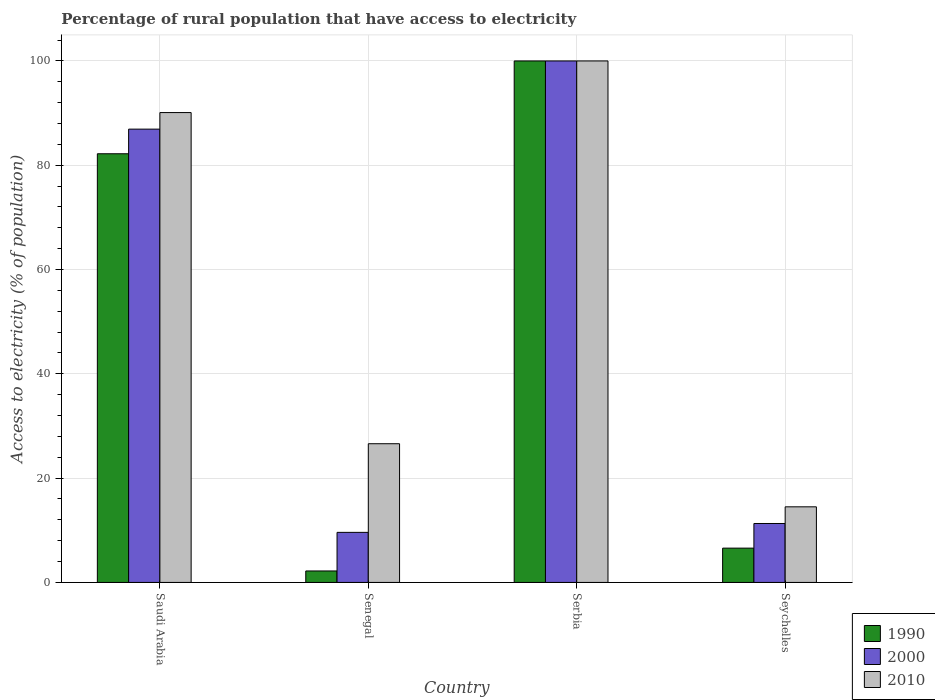How many different coloured bars are there?
Make the answer very short. 3. How many groups of bars are there?
Keep it short and to the point. 4. Are the number of bars per tick equal to the number of legend labels?
Keep it short and to the point. Yes. Are the number of bars on each tick of the X-axis equal?
Offer a terse response. Yes. How many bars are there on the 1st tick from the left?
Make the answer very short. 3. How many bars are there on the 2nd tick from the right?
Your response must be concise. 3. What is the label of the 2nd group of bars from the left?
Your response must be concise. Senegal. In how many cases, is the number of bars for a given country not equal to the number of legend labels?
Offer a very short reply. 0. What is the percentage of rural population that have access to electricity in 1990 in Seychelles?
Give a very brief answer. 6.58. Across all countries, what is the minimum percentage of rural population that have access to electricity in 2010?
Your answer should be compact. 14.5. In which country was the percentage of rural population that have access to electricity in 2000 maximum?
Your response must be concise. Serbia. In which country was the percentage of rural population that have access to electricity in 2000 minimum?
Make the answer very short. Senegal. What is the total percentage of rural population that have access to electricity in 2010 in the graph?
Give a very brief answer. 231.2. What is the difference between the percentage of rural population that have access to electricity in 2000 in Senegal and that in Seychelles?
Provide a short and direct response. -1.7. What is the difference between the percentage of rural population that have access to electricity in 2010 in Senegal and the percentage of rural population that have access to electricity in 1990 in Saudi Arabia?
Keep it short and to the point. -55.6. What is the average percentage of rural population that have access to electricity in 1990 per country?
Your answer should be compact. 47.75. What is the difference between the percentage of rural population that have access to electricity of/in 2010 and percentage of rural population that have access to electricity of/in 2000 in Senegal?
Keep it short and to the point. 17. In how many countries, is the percentage of rural population that have access to electricity in 2010 greater than 4 %?
Offer a terse response. 4. What is the ratio of the percentage of rural population that have access to electricity in 1990 in Saudi Arabia to that in Senegal?
Make the answer very short. 37.37. What is the difference between the highest and the second highest percentage of rural population that have access to electricity in 2000?
Your answer should be compact. -88.7. What is the difference between the highest and the lowest percentage of rural population that have access to electricity in 1990?
Offer a terse response. 97.8. In how many countries, is the percentage of rural population that have access to electricity in 1990 greater than the average percentage of rural population that have access to electricity in 1990 taken over all countries?
Ensure brevity in your answer.  2. Is it the case that in every country, the sum of the percentage of rural population that have access to electricity in 1990 and percentage of rural population that have access to electricity in 2010 is greater than the percentage of rural population that have access to electricity in 2000?
Give a very brief answer. Yes. How many countries are there in the graph?
Your answer should be very brief. 4. Are the values on the major ticks of Y-axis written in scientific E-notation?
Your answer should be very brief. No. Does the graph contain any zero values?
Your answer should be very brief. No. Where does the legend appear in the graph?
Your answer should be very brief. Bottom right. How are the legend labels stacked?
Offer a very short reply. Vertical. What is the title of the graph?
Provide a short and direct response. Percentage of rural population that have access to electricity. Does "1972" appear as one of the legend labels in the graph?
Provide a short and direct response. No. What is the label or title of the Y-axis?
Offer a terse response. Access to electricity (% of population). What is the Access to electricity (% of population) of 1990 in Saudi Arabia?
Give a very brief answer. 82.2. What is the Access to electricity (% of population) in 2000 in Saudi Arabia?
Your answer should be very brief. 86.93. What is the Access to electricity (% of population) of 2010 in Saudi Arabia?
Provide a succinct answer. 90.1. What is the Access to electricity (% of population) of 1990 in Senegal?
Make the answer very short. 2.2. What is the Access to electricity (% of population) in 2000 in Senegal?
Your response must be concise. 9.6. What is the Access to electricity (% of population) in 2010 in Senegal?
Provide a succinct answer. 26.6. What is the Access to electricity (% of population) of 1990 in Seychelles?
Offer a very short reply. 6.58. What is the Access to electricity (% of population) of 2000 in Seychelles?
Your answer should be very brief. 11.3. Across all countries, what is the maximum Access to electricity (% of population) in 1990?
Provide a short and direct response. 100. Across all countries, what is the minimum Access to electricity (% of population) of 1990?
Provide a short and direct response. 2.2. Across all countries, what is the minimum Access to electricity (% of population) of 2000?
Your response must be concise. 9.6. What is the total Access to electricity (% of population) of 1990 in the graph?
Provide a short and direct response. 190.98. What is the total Access to electricity (% of population) in 2000 in the graph?
Your answer should be compact. 207.83. What is the total Access to electricity (% of population) in 2010 in the graph?
Make the answer very short. 231.2. What is the difference between the Access to electricity (% of population) in 1990 in Saudi Arabia and that in Senegal?
Give a very brief answer. 80. What is the difference between the Access to electricity (% of population) in 2000 in Saudi Arabia and that in Senegal?
Your answer should be very brief. 77.33. What is the difference between the Access to electricity (% of population) in 2010 in Saudi Arabia and that in Senegal?
Offer a terse response. 63.5. What is the difference between the Access to electricity (% of population) of 1990 in Saudi Arabia and that in Serbia?
Offer a terse response. -17.8. What is the difference between the Access to electricity (% of population) in 2000 in Saudi Arabia and that in Serbia?
Provide a short and direct response. -13.07. What is the difference between the Access to electricity (% of population) in 1990 in Saudi Arabia and that in Seychelles?
Provide a short and direct response. 75.62. What is the difference between the Access to electricity (% of population) of 2000 in Saudi Arabia and that in Seychelles?
Your answer should be very brief. 75.62. What is the difference between the Access to electricity (% of population) in 2010 in Saudi Arabia and that in Seychelles?
Give a very brief answer. 75.6. What is the difference between the Access to electricity (% of population) in 1990 in Senegal and that in Serbia?
Provide a succinct answer. -97.8. What is the difference between the Access to electricity (% of population) in 2000 in Senegal and that in Serbia?
Ensure brevity in your answer.  -90.4. What is the difference between the Access to electricity (% of population) of 2010 in Senegal and that in Serbia?
Ensure brevity in your answer.  -73.4. What is the difference between the Access to electricity (% of population) of 1990 in Senegal and that in Seychelles?
Your response must be concise. -4.38. What is the difference between the Access to electricity (% of population) in 2000 in Senegal and that in Seychelles?
Keep it short and to the point. -1.7. What is the difference between the Access to electricity (% of population) in 2010 in Senegal and that in Seychelles?
Provide a short and direct response. 12.1. What is the difference between the Access to electricity (% of population) of 1990 in Serbia and that in Seychelles?
Offer a terse response. 93.42. What is the difference between the Access to electricity (% of population) of 2000 in Serbia and that in Seychelles?
Provide a short and direct response. 88.7. What is the difference between the Access to electricity (% of population) of 2010 in Serbia and that in Seychelles?
Keep it short and to the point. 85.5. What is the difference between the Access to electricity (% of population) in 1990 in Saudi Arabia and the Access to electricity (% of population) in 2000 in Senegal?
Offer a terse response. 72.6. What is the difference between the Access to electricity (% of population) in 1990 in Saudi Arabia and the Access to electricity (% of population) in 2010 in Senegal?
Provide a succinct answer. 55.6. What is the difference between the Access to electricity (% of population) of 2000 in Saudi Arabia and the Access to electricity (% of population) of 2010 in Senegal?
Give a very brief answer. 60.33. What is the difference between the Access to electricity (% of population) in 1990 in Saudi Arabia and the Access to electricity (% of population) in 2000 in Serbia?
Give a very brief answer. -17.8. What is the difference between the Access to electricity (% of population) in 1990 in Saudi Arabia and the Access to electricity (% of population) in 2010 in Serbia?
Keep it short and to the point. -17.8. What is the difference between the Access to electricity (% of population) in 2000 in Saudi Arabia and the Access to electricity (% of population) in 2010 in Serbia?
Provide a short and direct response. -13.07. What is the difference between the Access to electricity (% of population) of 1990 in Saudi Arabia and the Access to electricity (% of population) of 2000 in Seychelles?
Provide a succinct answer. 70.9. What is the difference between the Access to electricity (% of population) in 1990 in Saudi Arabia and the Access to electricity (% of population) in 2010 in Seychelles?
Give a very brief answer. 67.7. What is the difference between the Access to electricity (% of population) of 2000 in Saudi Arabia and the Access to electricity (% of population) of 2010 in Seychelles?
Provide a succinct answer. 72.43. What is the difference between the Access to electricity (% of population) of 1990 in Senegal and the Access to electricity (% of population) of 2000 in Serbia?
Your answer should be compact. -97.8. What is the difference between the Access to electricity (% of population) of 1990 in Senegal and the Access to electricity (% of population) of 2010 in Serbia?
Provide a succinct answer. -97.8. What is the difference between the Access to electricity (% of population) in 2000 in Senegal and the Access to electricity (% of population) in 2010 in Serbia?
Provide a short and direct response. -90.4. What is the difference between the Access to electricity (% of population) in 1990 in Senegal and the Access to electricity (% of population) in 2000 in Seychelles?
Your answer should be very brief. -9.1. What is the difference between the Access to electricity (% of population) of 1990 in Senegal and the Access to electricity (% of population) of 2010 in Seychelles?
Ensure brevity in your answer.  -12.3. What is the difference between the Access to electricity (% of population) in 2000 in Senegal and the Access to electricity (% of population) in 2010 in Seychelles?
Your answer should be compact. -4.9. What is the difference between the Access to electricity (% of population) in 1990 in Serbia and the Access to electricity (% of population) in 2000 in Seychelles?
Offer a terse response. 88.7. What is the difference between the Access to electricity (% of population) of 1990 in Serbia and the Access to electricity (% of population) of 2010 in Seychelles?
Offer a terse response. 85.5. What is the difference between the Access to electricity (% of population) of 2000 in Serbia and the Access to electricity (% of population) of 2010 in Seychelles?
Keep it short and to the point. 85.5. What is the average Access to electricity (% of population) in 1990 per country?
Make the answer very short. 47.75. What is the average Access to electricity (% of population) of 2000 per country?
Provide a succinct answer. 51.96. What is the average Access to electricity (% of population) in 2010 per country?
Your response must be concise. 57.8. What is the difference between the Access to electricity (% of population) of 1990 and Access to electricity (% of population) of 2000 in Saudi Arabia?
Make the answer very short. -4.72. What is the difference between the Access to electricity (% of population) of 1990 and Access to electricity (% of population) of 2010 in Saudi Arabia?
Offer a terse response. -7.9. What is the difference between the Access to electricity (% of population) of 2000 and Access to electricity (% of population) of 2010 in Saudi Arabia?
Make the answer very short. -3.17. What is the difference between the Access to electricity (% of population) in 1990 and Access to electricity (% of population) in 2000 in Senegal?
Keep it short and to the point. -7.4. What is the difference between the Access to electricity (% of population) of 1990 and Access to electricity (% of population) of 2010 in Senegal?
Give a very brief answer. -24.4. What is the difference between the Access to electricity (% of population) of 2000 and Access to electricity (% of population) of 2010 in Senegal?
Offer a terse response. -17. What is the difference between the Access to electricity (% of population) of 1990 and Access to electricity (% of population) of 2000 in Serbia?
Provide a succinct answer. 0. What is the difference between the Access to electricity (% of population) in 2000 and Access to electricity (% of population) in 2010 in Serbia?
Provide a short and direct response. 0. What is the difference between the Access to electricity (% of population) in 1990 and Access to electricity (% of population) in 2000 in Seychelles?
Your answer should be compact. -4.72. What is the difference between the Access to electricity (% of population) of 1990 and Access to electricity (% of population) of 2010 in Seychelles?
Provide a short and direct response. -7.92. What is the difference between the Access to electricity (% of population) of 2000 and Access to electricity (% of population) of 2010 in Seychelles?
Give a very brief answer. -3.2. What is the ratio of the Access to electricity (% of population) of 1990 in Saudi Arabia to that in Senegal?
Your response must be concise. 37.37. What is the ratio of the Access to electricity (% of population) of 2000 in Saudi Arabia to that in Senegal?
Keep it short and to the point. 9.05. What is the ratio of the Access to electricity (% of population) of 2010 in Saudi Arabia to that in Senegal?
Provide a short and direct response. 3.39. What is the ratio of the Access to electricity (% of population) in 1990 in Saudi Arabia to that in Serbia?
Offer a very short reply. 0.82. What is the ratio of the Access to electricity (% of population) in 2000 in Saudi Arabia to that in Serbia?
Ensure brevity in your answer.  0.87. What is the ratio of the Access to electricity (% of population) in 2010 in Saudi Arabia to that in Serbia?
Your answer should be compact. 0.9. What is the ratio of the Access to electricity (% of population) in 1990 in Saudi Arabia to that in Seychelles?
Make the answer very short. 12.49. What is the ratio of the Access to electricity (% of population) of 2000 in Saudi Arabia to that in Seychelles?
Your answer should be very brief. 7.69. What is the ratio of the Access to electricity (% of population) in 2010 in Saudi Arabia to that in Seychelles?
Your answer should be compact. 6.21. What is the ratio of the Access to electricity (% of population) of 1990 in Senegal to that in Serbia?
Your answer should be compact. 0.02. What is the ratio of the Access to electricity (% of population) of 2000 in Senegal to that in Serbia?
Offer a very short reply. 0.1. What is the ratio of the Access to electricity (% of population) in 2010 in Senegal to that in Serbia?
Make the answer very short. 0.27. What is the ratio of the Access to electricity (% of population) of 1990 in Senegal to that in Seychelles?
Ensure brevity in your answer.  0.33. What is the ratio of the Access to electricity (% of population) in 2000 in Senegal to that in Seychelles?
Offer a very short reply. 0.85. What is the ratio of the Access to electricity (% of population) of 2010 in Senegal to that in Seychelles?
Provide a succinct answer. 1.83. What is the ratio of the Access to electricity (% of population) in 1990 in Serbia to that in Seychelles?
Your answer should be compact. 15.2. What is the ratio of the Access to electricity (% of population) in 2000 in Serbia to that in Seychelles?
Keep it short and to the point. 8.85. What is the ratio of the Access to electricity (% of population) in 2010 in Serbia to that in Seychelles?
Your answer should be very brief. 6.9. What is the difference between the highest and the second highest Access to electricity (% of population) in 1990?
Your answer should be very brief. 17.8. What is the difference between the highest and the second highest Access to electricity (% of population) in 2000?
Offer a very short reply. 13.07. What is the difference between the highest and the lowest Access to electricity (% of population) in 1990?
Make the answer very short. 97.8. What is the difference between the highest and the lowest Access to electricity (% of population) of 2000?
Give a very brief answer. 90.4. What is the difference between the highest and the lowest Access to electricity (% of population) of 2010?
Your answer should be very brief. 85.5. 